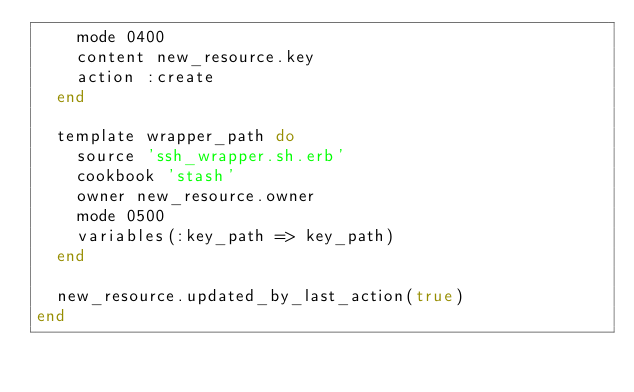Convert code to text. <code><loc_0><loc_0><loc_500><loc_500><_Ruby_>    mode 0400
    content new_resource.key
    action :create
  end

  template wrapper_path do
    source 'ssh_wrapper.sh.erb'
    cookbook 'stash'
    owner new_resource.owner
    mode 0500
    variables(:key_path => key_path)
  end

  new_resource.updated_by_last_action(true)
end
</code> 